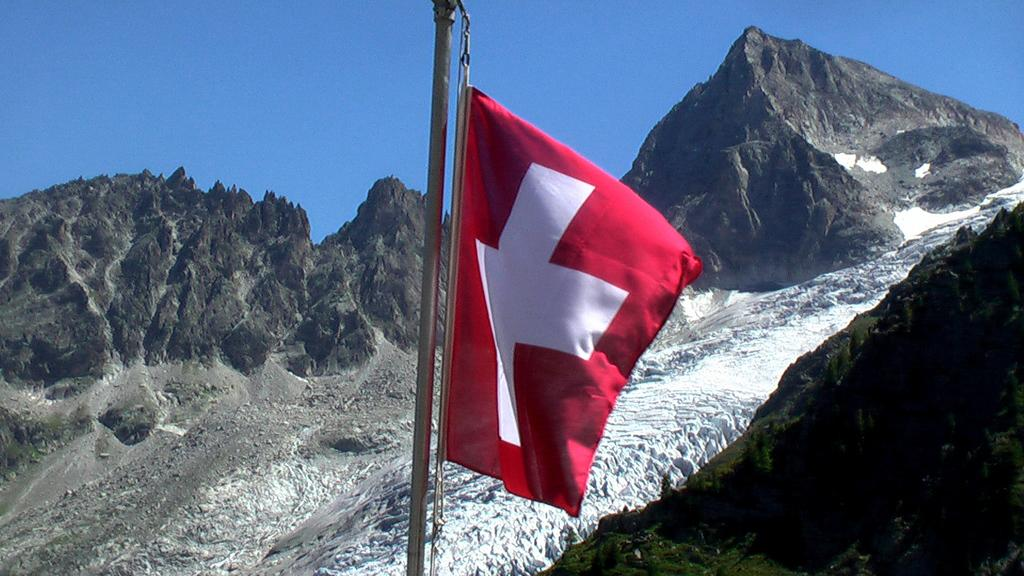What type of natural formation can be seen in the image? There are mountains in the image. What is attached to the pole in the image? There is a red flag on the pole in the image. What is covering the ground in the image? There is snow on the ground in the image. What is visible at the top of the image? The sky is visible at the top of the image. Where is the church located in the image? There is no church present in the image. What type of ray is emitting from the mountains in the image? There are no rays emitting from the mountains in the image. 